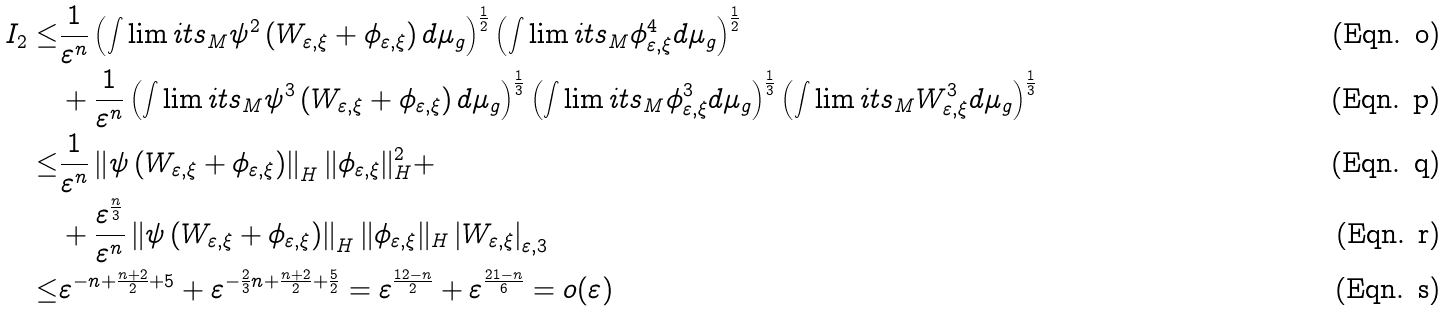Convert formula to latex. <formula><loc_0><loc_0><loc_500><loc_500>I _ { 2 } \leq & \frac { 1 } { \varepsilon ^ { n } } \left ( { \int \lim i t s _ { M } } \psi ^ { 2 } \left ( W _ { \varepsilon , \xi } + \phi _ { \varepsilon , \xi } \right ) d \mu _ { g } \right ) ^ { \frac { 1 } { 2 } } \left ( { \int \lim i t s _ { M } } \phi _ { \varepsilon , \xi } ^ { 4 } d \mu _ { g } \right ) ^ { \frac { 1 } { 2 } } \\ & + \frac { 1 } { \varepsilon ^ { n } } \left ( { \int \lim i t s _ { M } } \psi ^ { 3 } \left ( W _ { \varepsilon , \xi } + \phi _ { \varepsilon , \xi } \right ) d \mu _ { g } \right ) ^ { \frac { 1 } { 3 } } \left ( { \int \lim i t s _ { M } } \phi _ { \varepsilon , \xi } ^ { 3 } d \mu _ { g } \right ) ^ { \frac { 1 } { 3 } } \left ( { \int \lim i t s _ { M } } W _ { \varepsilon , \xi } ^ { 3 } d \mu _ { g } \right ) ^ { \frac { 1 } { 3 } } \\ \leq & \frac { 1 } { \varepsilon ^ { n } } \left \| \psi \left ( W _ { \varepsilon , \xi } + \phi _ { \varepsilon , \xi } \right ) \right \| _ { H } \| \phi _ { \varepsilon , \xi } \| _ { H } ^ { 2 } + \\ & + \frac { \varepsilon ^ { \frac { n } { 3 } } } { \varepsilon ^ { n } } \left \| \psi \left ( W _ { \varepsilon , \xi } + \phi _ { \varepsilon , \xi } \right ) \right \| _ { H } \| \phi _ { \varepsilon , \xi } \| _ { H } \left | W _ { \varepsilon , \xi } \right | _ { \varepsilon , 3 } \\ \leq & \varepsilon ^ { - n + \frac { n + 2 } { 2 } + 5 } + \varepsilon ^ { - \frac { 2 } { 3 } n + \frac { n + 2 } { 2 } + \frac { 5 } { 2 } } = \varepsilon ^ { \frac { 1 2 - n } { 2 } } + \varepsilon ^ { \frac { 2 1 - n } { 6 } } = o ( \varepsilon )</formula> 